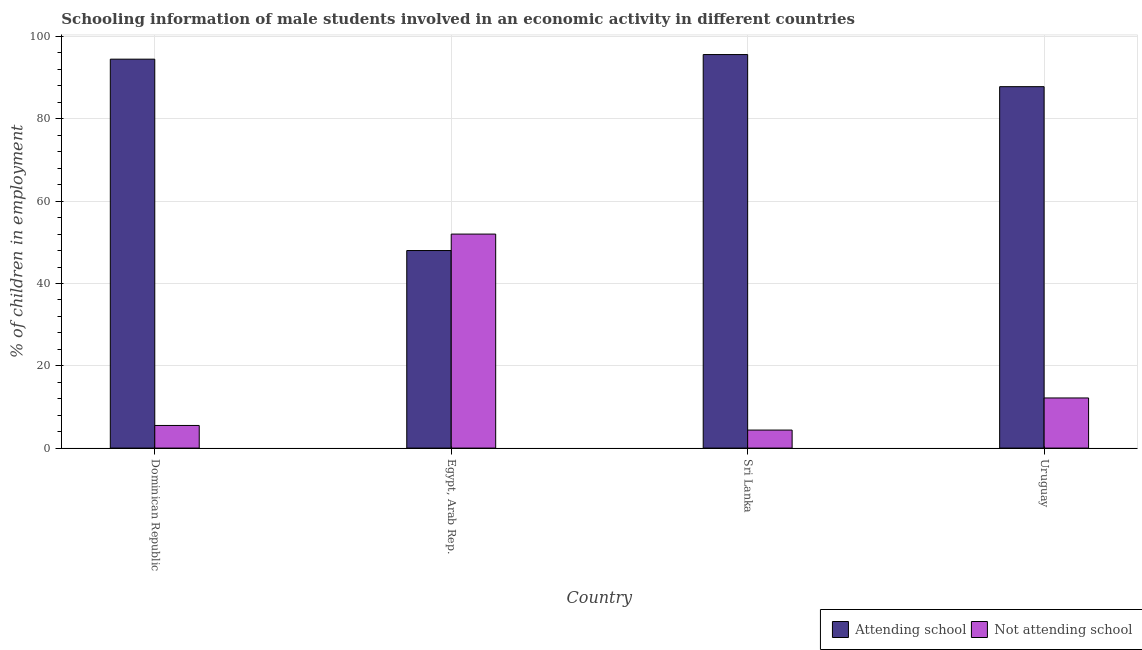How many groups of bars are there?
Give a very brief answer. 4. Are the number of bars per tick equal to the number of legend labels?
Offer a terse response. Yes. Are the number of bars on each tick of the X-axis equal?
Ensure brevity in your answer.  Yes. How many bars are there on the 4th tick from the left?
Keep it short and to the point. 2. What is the label of the 3rd group of bars from the left?
Make the answer very short. Sri Lanka. What is the percentage of employed males who are attending school in Uruguay?
Ensure brevity in your answer.  87.82. Across all countries, what is the maximum percentage of employed males who are not attending school?
Your response must be concise. 52. Across all countries, what is the minimum percentage of employed males who are not attending school?
Your response must be concise. 4.38. In which country was the percentage of employed males who are not attending school maximum?
Provide a succinct answer. Egypt, Arab Rep. In which country was the percentage of employed males who are attending school minimum?
Your answer should be compact. Egypt, Arab Rep. What is the total percentage of employed males who are attending school in the graph?
Provide a short and direct response. 325.94. What is the difference between the percentage of employed males who are not attending school in Egypt, Arab Rep. and that in Sri Lanka?
Ensure brevity in your answer.  47.62. What is the difference between the percentage of employed males who are not attending school in Uruguay and the percentage of employed males who are attending school in Egypt, Arab Rep.?
Your response must be concise. -35.82. What is the average percentage of employed males who are attending school per country?
Offer a very short reply. 81.48. What is the difference between the percentage of employed males who are not attending school and percentage of employed males who are attending school in Egypt, Arab Rep.?
Make the answer very short. 4. What is the ratio of the percentage of employed males who are not attending school in Dominican Republic to that in Egypt, Arab Rep.?
Keep it short and to the point. 0.11. Is the percentage of employed males who are not attending school in Egypt, Arab Rep. less than that in Sri Lanka?
Keep it short and to the point. No. Is the difference between the percentage of employed males who are not attending school in Egypt, Arab Rep. and Sri Lanka greater than the difference between the percentage of employed males who are attending school in Egypt, Arab Rep. and Sri Lanka?
Provide a short and direct response. Yes. What is the difference between the highest and the second highest percentage of employed males who are attending school?
Provide a short and direct response. 1.12. What is the difference between the highest and the lowest percentage of employed males who are attending school?
Provide a short and direct response. 47.62. In how many countries, is the percentage of employed males who are not attending school greater than the average percentage of employed males who are not attending school taken over all countries?
Give a very brief answer. 1. What does the 1st bar from the left in Dominican Republic represents?
Give a very brief answer. Attending school. What does the 1st bar from the right in Dominican Republic represents?
Provide a succinct answer. Not attending school. Are all the bars in the graph horizontal?
Provide a short and direct response. No. How many countries are there in the graph?
Offer a terse response. 4. Does the graph contain grids?
Make the answer very short. Yes. Where does the legend appear in the graph?
Offer a very short reply. Bottom right. How many legend labels are there?
Keep it short and to the point. 2. How are the legend labels stacked?
Provide a succinct answer. Horizontal. What is the title of the graph?
Provide a succinct answer. Schooling information of male students involved in an economic activity in different countries. What is the label or title of the X-axis?
Give a very brief answer. Country. What is the label or title of the Y-axis?
Provide a short and direct response. % of children in employment. What is the % of children in employment of Attending school in Dominican Republic?
Offer a very short reply. 94.5. What is the % of children in employment of Attending school in Egypt, Arab Rep.?
Your answer should be very brief. 48. What is the % of children in employment in Not attending school in Egypt, Arab Rep.?
Give a very brief answer. 52. What is the % of children in employment in Attending school in Sri Lanka?
Make the answer very short. 95.62. What is the % of children in employment in Not attending school in Sri Lanka?
Your answer should be compact. 4.38. What is the % of children in employment of Attending school in Uruguay?
Offer a very short reply. 87.82. What is the % of children in employment of Not attending school in Uruguay?
Your response must be concise. 12.18. Across all countries, what is the maximum % of children in employment of Attending school?
Give a very brief answer. 95.62. Across all countries, what is the minimum % of children in employment of Attending school?
Make the answer very short. 48. Across all countries, what is the minimum % of children in employment of Not attending school?
Your answer should be compact. 4.38. What is the total % of children in employment in Attending school in the graph?
Make the answer very short. 325.94. What is the total % of children in employment in Not attending school in the graph?
Provide a succinct answer. 74.06. What is the difference between the % of children in employment in Attending school in Dominican Republic and that in Egypt, Arab Rep.?
Give a very brief answer. 46.5. What is the difference between the % of children in employment of Not attending school in Dominican Republic and that in Egypt, Arab Rep.?
Your answer should be compact. -46.5. What is the difference between the % of children in employment in Attending school in Dominican Republic and that in Sri Lanka?
Provide a short and direct response. -1.12. What is the difference between the % of children in employment in Not attending school in Dominican Republic and that in Sri Lanka?
Your answer should be compact. 1.12. What is the difference between the % of children in employment in Attending school in Dominican Republic and that in Uruguay?
Keep it short and to the point. 6.68. What is the difference between the % of children in employment of Not attending school in Dominican Republic and that in Uruguay?
Make the answer very short. -6.68. What is the difference between the % of children in employment in Attending school in Egypt, Arab Rep. and that in Sri Lanka?
Your answer should be compact. -47.62. What is the difference between the % of children in employment in Not attending school in Egypt, Arab Rep. and that in Sri Lanka?
Provide a short and direct response. 47.62. What is the difference between the % of children in employment of Attending school in Egypt, Arab Rep. and that in Uruguay?
Keep it short and to the point. -39.82. What is the difference between the % of children in employment in Not attending school in Egypt, Arab Rep. and that in Uruguay?
Keep it short and to the point. 39.82. What is the difference between the % of children in employment in Attending school in Sri Lanka and that in Uruguay?
Provide a succinct answer. 7.8. What is the difference between the % of children in employment in Not attending school in Sri Lanka and that in Uruguay?
Keep it short and to the point. -7.8. What is the difference between the % of children in employment of Attending school in Dominican Republic and the % of children in employment of Not attending school in Egypt, Arab Rep.?
Ensure brevity in your answer.  42.5. What is the difference between the % of children in employment in Attending school in Dominican Republic and the % of children in employment in Not attending school in Sri Lanka?
Your answer should be very brief. 90.12. What is the difference between the % of children in employment in Attending school in Dominican Republic and the % of children in employment in Not attending school in Uruguay?
Provide a succinct answer. 82.32. What is the difference between the % of children in employment in Attending school in Egypt, Arab Rep. and the % of children in employment in Not attending school in Sri Lanka?
Your answer should be compact. 43.62. What is the difference between the % of children in employment of Attending school in Egypt, Arab Rep. and the % of children in employment of Not attending school in Uruguay?
Give a very brief answer. 35.82. What is the difference between the % of children in employment of Attending school in Sri Lanka and the % of children in employment of Not attending school in Uruguay?
Offer a very short reply. 83.44. What is the average % of children in employment in Attending school per country?
Ensure brevity in your answer.  81.48. What is the average % of children in employment in Not attending school per country?
Keep it short and to the point. 18.52. What is the difference between the % of children in employment of Attending school and % of children in employment of Not attending school in Dominican Republic?
Give a very brief answer. 89. What is the difference between the % of children in employment of Attending school and % of children in employment of Not attending school in Egypt, Arab Rep.?
Your answer should be very brief. -4. What is the difference between the % of children in employment in Attending school and % of children in employment in Not attending school in Sri Lanka?
Provide a short and direct response. 91.24. What is the difference between the % of children in employment in Attending school and % of children in employment in Not attending school in Uruguay?
Your answer should be compact. 75.64. What is the ratio of the % of children in employment in Attending school in Dominican Republic to that in Egypt, Arab Rep.?
Provide a short and direct response. 1.97. What is the ratio of the % of children in employment in Not attending school in Dominican Republic to that in Egypt, Arab Rep.?
Ensure brevity in your answer.  0.11. What is the ratio of the % of children in employment in Attending school in Dominican Republic to that in Sri Lanka?
Make the answer very short. 0.99. What is the ratio of the % of children in employment in Not attending school in Dominican Republic to that in Sri Lanka?
Give a very brief answer. 1.26. What is the ratio of the % of children in employment in Attending school in Dominican Republic to that in Uruguay?
Your answer should be compact. 1.08. What is the ratio of the % of children in employment in Not attending school in Dominican Republic to that in Uruguay?
Make the answer very short. 0.45. What is the ratio of the % of children in employment in Attending school in Egypt, Arab Rep. to that in Sri Lanka?
Your response must be concise. 0.5. What is the ratio of the % of children in employment in Not attending school in Egypt, Arab Rep. to that in Sri Lanka?
Ensure brevity in your answer.  11.87. What is the ratio of the % of children in employment in Attending school in Egypt, Arab Rep. to that in Uruguay?
Offer a terse response. 0.55. What is the ratio of the % of children in employment in Not attending school in Egypt, Arab Rep. to that in Uruguay?
Your answer should be very brief. 4.27. What is the ratio of the % of children in employment of Attending school in Sri Lanka to that in Uruguay?
Offer a terse response. 1.09. What is the ratio of the % of children in employment of Not attending school in Sri Lanka to that in Uruguay?
Give a very brief answer. 0.36. What is the difference between the highest and the second highest % of children in employment in Attending school?
Give a very brief answer. 1.12. What is the difference between the highest and the second highest % of children in employment of Not attending school?
Your response must be concise. 39.82. What is the difference between the highest and the lowest % of children in employment of Attending school?
Your response must be concise. 47.62. What is the difference between the highest and the lowest % of children in employment of Not attending school?
Your answer should be compact. 47.62. 